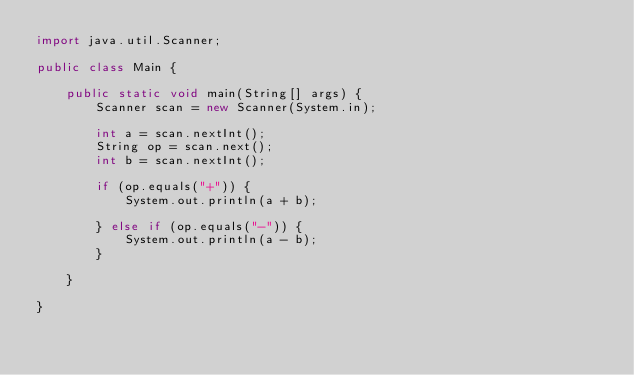Convert code to text. <code><loc_0><loc_0><loc_500><loc_500><_Java_>import java.util.Scanner;

public class Main {

	public static void main(String[] args) {
		Scanner scan = new Scanner(System.in);

		int a = scan.nextInt();
		String op = scan.next();
		int b = scan.nextInt();

		if (op.equals("+")) {
			System.out.println(a + b);

		} else if (op.equals("-")) {
			System.out.println(a - b);
		}

	}

}</code> 